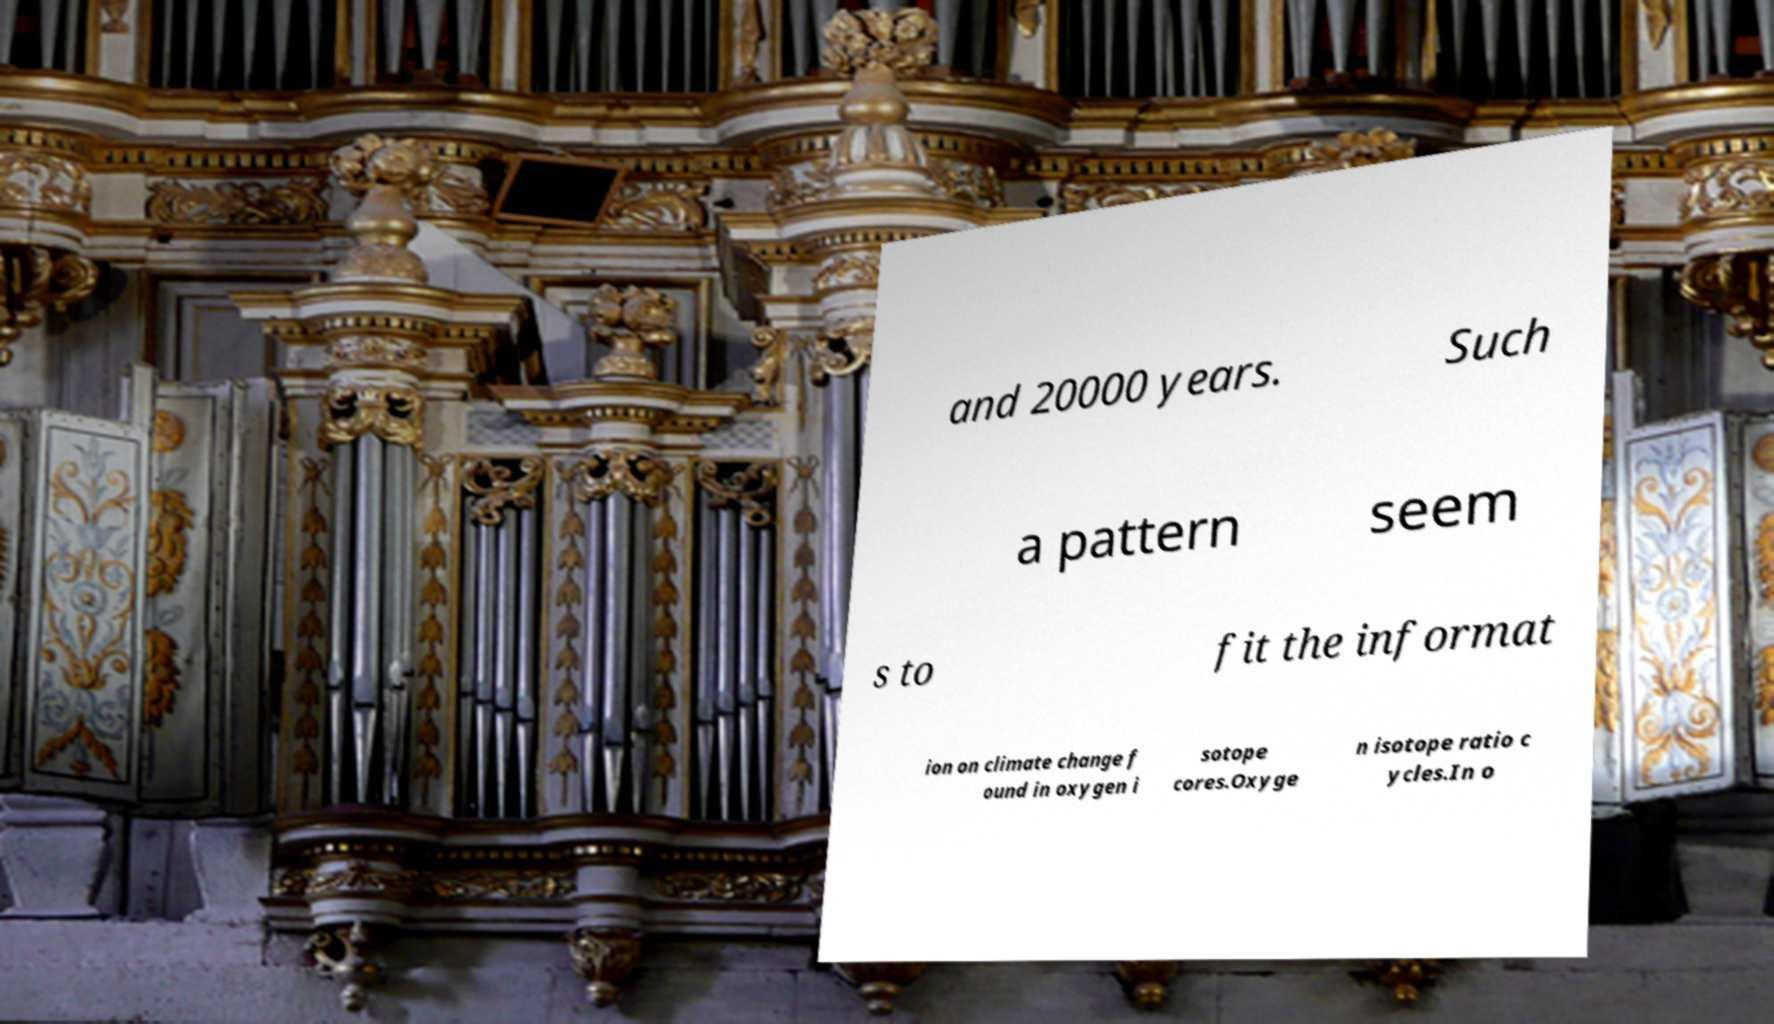Please identify and transcribe the text found in this image. and 20000 years. Such a pattern seem s to fit the informat ion on climate change f ound in oxygen i sotope cores.Oxyge n isotope ratio c ycles.In o 